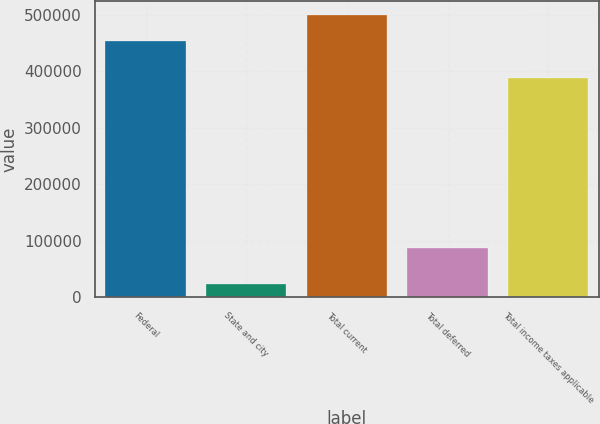Convert chart to OTSL. <chart><loc_0><loc_0><loc_500><loc_500><bar_chart><fcel>Federal<fcel>State and city<fcel>Total current<fcel>Total deferred<fcel>Total income taxes applicable<nl><fcel>453425<fcel>23382<fcel>498768<fcel>88071<fcel>388736<nl></chart> 